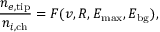Convert formula to latex. <formula><loc_0><loc_0><loc_500><loc_500>\frac { n _ { e , t i p } } { n _ { i , c h } } = F ( v , R , E _ { \max } , E _ { b g } ) ,</formula> 